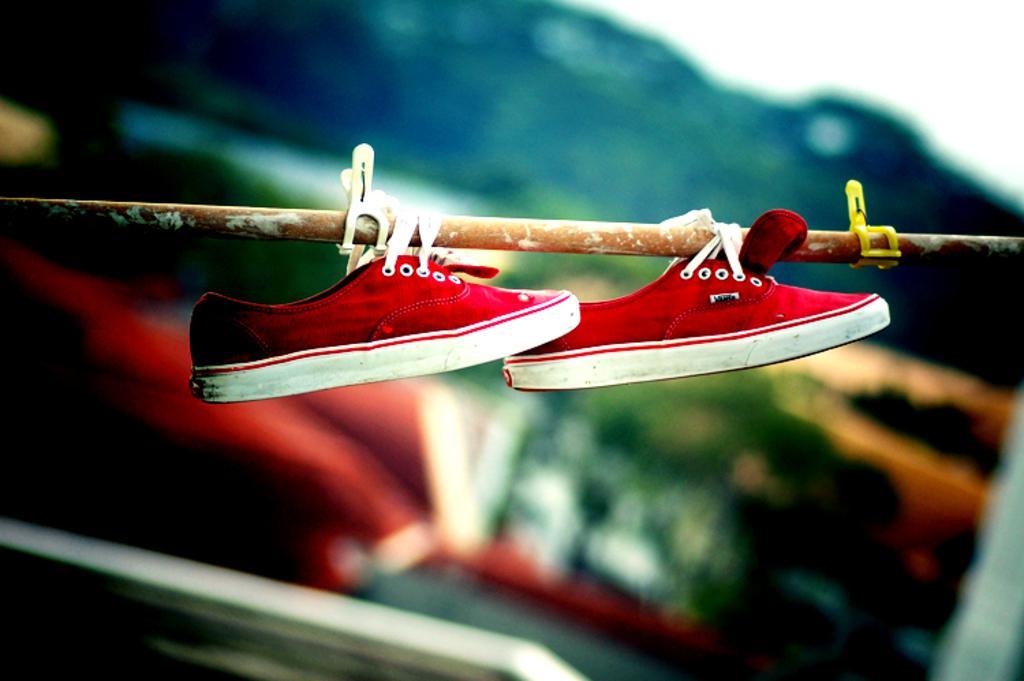Could you give a brief overview of what you see in this image? In this image we can see the shoes which are hanging to the iron fence. And we can see the two clips. And we can see the background is blurred. 